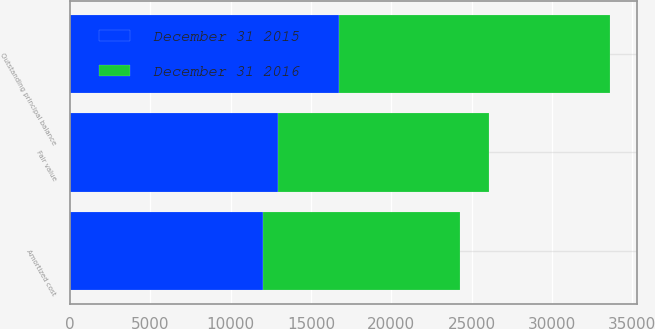Convert chart. <chart><loc_0><loc_0><loc_500><loc_500><stacked_bar_chart><ecel><fcel>Outstanding principal balance<fcel>Amortized cost<fcel>Fair value<nl><fcel>December 31 2015<fcel>16728<fcel>11987<fcel>12922<nl><fcel>December 31 2016<fcel>16871<fcel>12303<fcel>13164<nl></chart> 